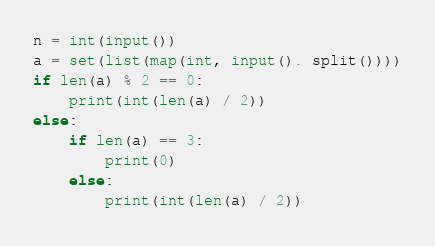Convert code to text. <code><loc_0><loc_0><loc_500><loc_500><_Python_>n = int(input())
a = set(list(map(int, input(). split())))
if len(a) % 2 == 0:
    print(int(len(a) / 2))
else:
    if len(a) == 3:
        print(0)
    else:
        print(int(len(a) / 2))


</code> 